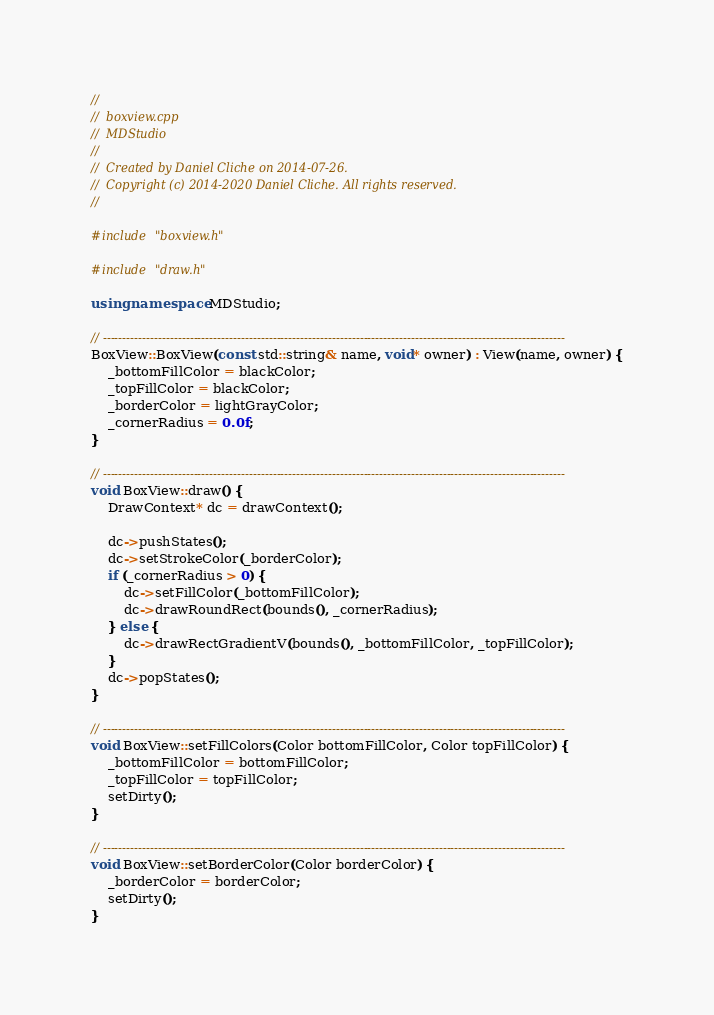Convert code to text. <code><loc_0><loc_0><loc_500><loc_500><_C++_>//
//  boxview.cpp
//  MDStudio
//
//  Created by Daniel Cliche on 2014-07-26.
//  Copyright (c) 2014-2020 Daniel Cliche. All rights reserved.
//

#include "boxview.h"

#include "draw.h"

using namespace MDStudio;

// ---------------------------------------------------------------------------------------------------------------------
BoxView::BoxView(const std::string& name, void* owner) : View(name, owner) {
    _bottomFillColor = blackColor;
    _topFillColor = blackColor;
    _borderColor = lightGrayColor;
    _cornerRadius = 0.0f;
}

// ---------------------------------------------------------------------------------------------------------------------
void BoxView::draw() {
    DrawContext* dc = drawContext();

    dc->pushStates();
    dc->setStrokeColor(_borderColor);
    if (_cornerRadius > 0) {
        dc->setFillColor(_bottomFillColor);
        dc->drawRoundRect(bounds(), _cornerRadius);
    } else {
        dc->drawRectGradientV(bounds(), _bottomFillColor, _topFillColor);
    }
    dc->popStates();
}

// ---------------------------------------------------------------------------------------------------------------------
void BoxView::setFillColors(Color bottomFillColor, Color topFillColor) {
    _bottomFillColor = bottomFillColor;
    _topFillColor = topFillColor;
    setDirty();
}

// ---------------------------------------------------------------------------------------------------------------------
void BoxView::setBorderColor(Color borderColor) {
    _borderColor = borderColor;
    setDirty();
}
</code> 